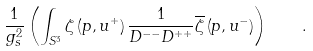Convert formula to latex. <formula><loc_0><loc_0><loc_500><loc_500>\frac { 1 } { g _ { s } ^ { 2 } } \left ( \int _ { S ^ { 3 } } \zeta \left ( p , u ^ { + } \right ) \frac { 1 } { D ^ { - - } D ^ { + + } } \overline { \zeta } \left ( p , u ^ { - } \right ) \right ) \quad .</formula> 